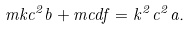Convert formula to latex. <formula><loc_0><loc_0><loc_500><loc_500>m k c ^ { 2 } b + m c d f = k ^ { 2 } c ^ { 2 } a .</formula> 